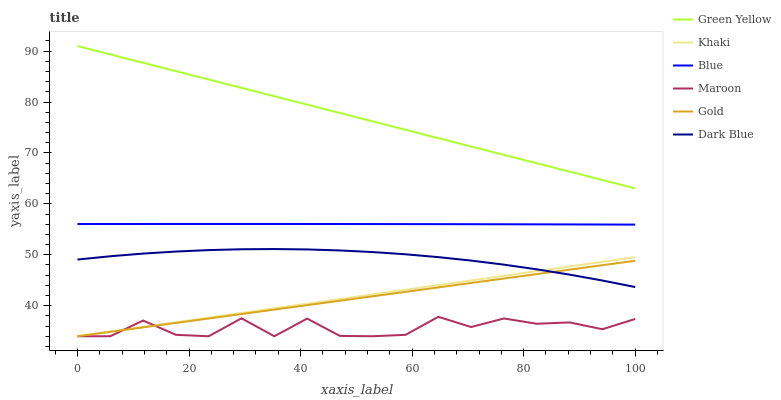Does Maroon have the minimum area under the curve?
Answer yes or no. Yes. Does Green Yellow have the maximum area under the curve?
Answer yes or no. Yes. Does Khaki have the minimum area under the curve?
Answer yes or no. No. Does Khaki have the maximum area under the curve?
Answer yes or no. No. Is Gold the smoothest?
Answer yes or no. Yes. Is Maroon the roughest?
Answer yes or no. Yes. Is Khaki the smoothest?
Answer yes or no. No. Is Khaki the roughest?
Answer yes or no. No. Does Khaki have the lowest value?
Answer yes or no. Yes. Does Dark Blue have the lowest value?
Answer yes or no. No. Does Green Yellow have the highest value?
Answer yes or no. Yes. Does Khaki have the highest value?
Answer yes or no. No. Is Gold less than Green Yellow?
Answer yes or no. Yes. Is Green Yellow greater than Khaki?
Answer yes or no. Yes. Does Dark Blue intersect Khaki?
Answer yes or no. Yes. Is Dark Blue less than Khaki?
Answer yes or no. No. Is Dark Blue greater than Khaki?
Answer yes or no. No. Does Gold intersect Green Yellow?
Answer yes or no. No. 